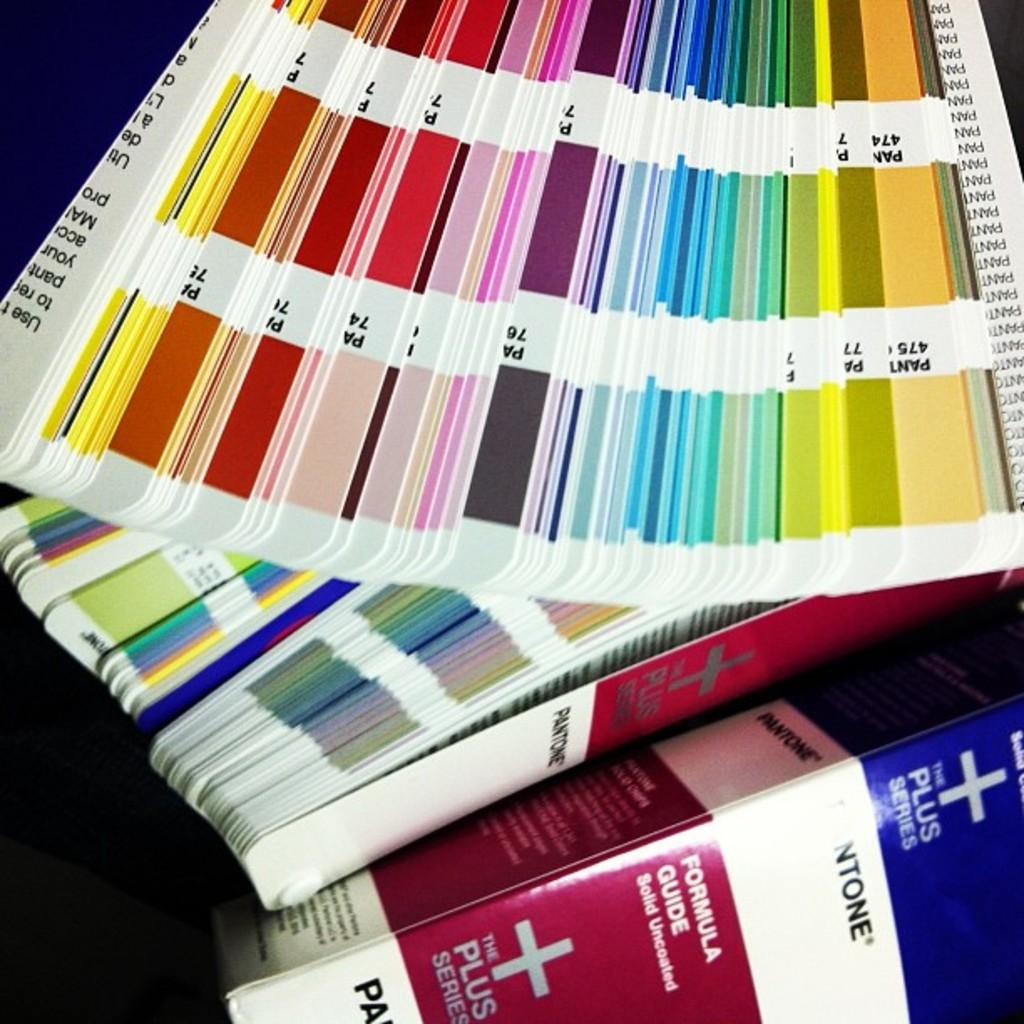Provide a one-sentence caption for the provided image. A series of different colored pages next to a Pantone Formula Guide. 